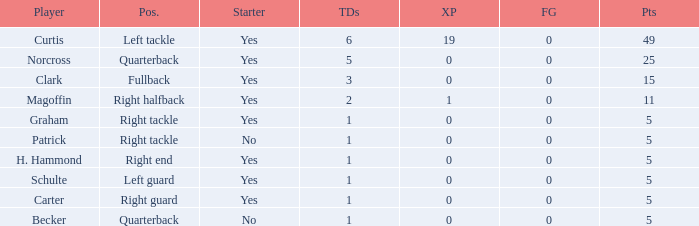Name the most field goals 0.0. 